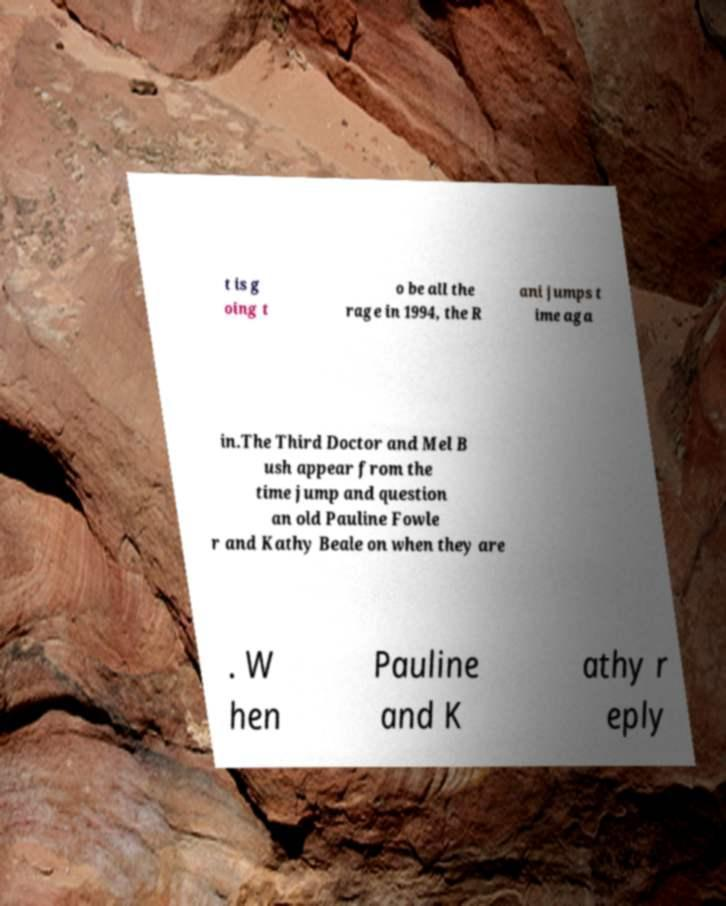Please read and relay the text visible in this image. What does it say? t is g oing t o be all the rage in 1994, the R ani jumps t ime aga in.The Third Doctor and Mel B ush appear from the time jump and question an old Pauline Fowle r and Kathy Beale on when they are . W hen Pauline and K athy r eply 